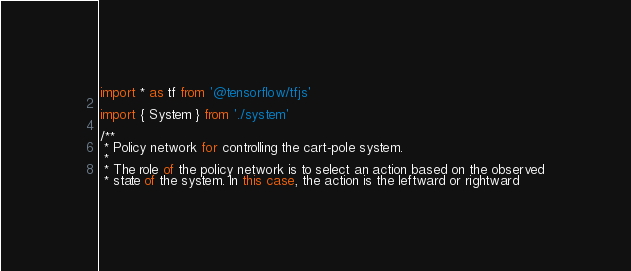<code> <loc_0><loc_0><loc_500><loc_500><_TypeScript_>import * as tf from '@tensorflow/tfjs'

import { System } from './system'

/**
 * Policy network for controlling the cart-pole system.
 *
 * The role of the policy network is to select an action based on the observed
 * state of the system. In this case, the action is the leftward or rightward</code> 